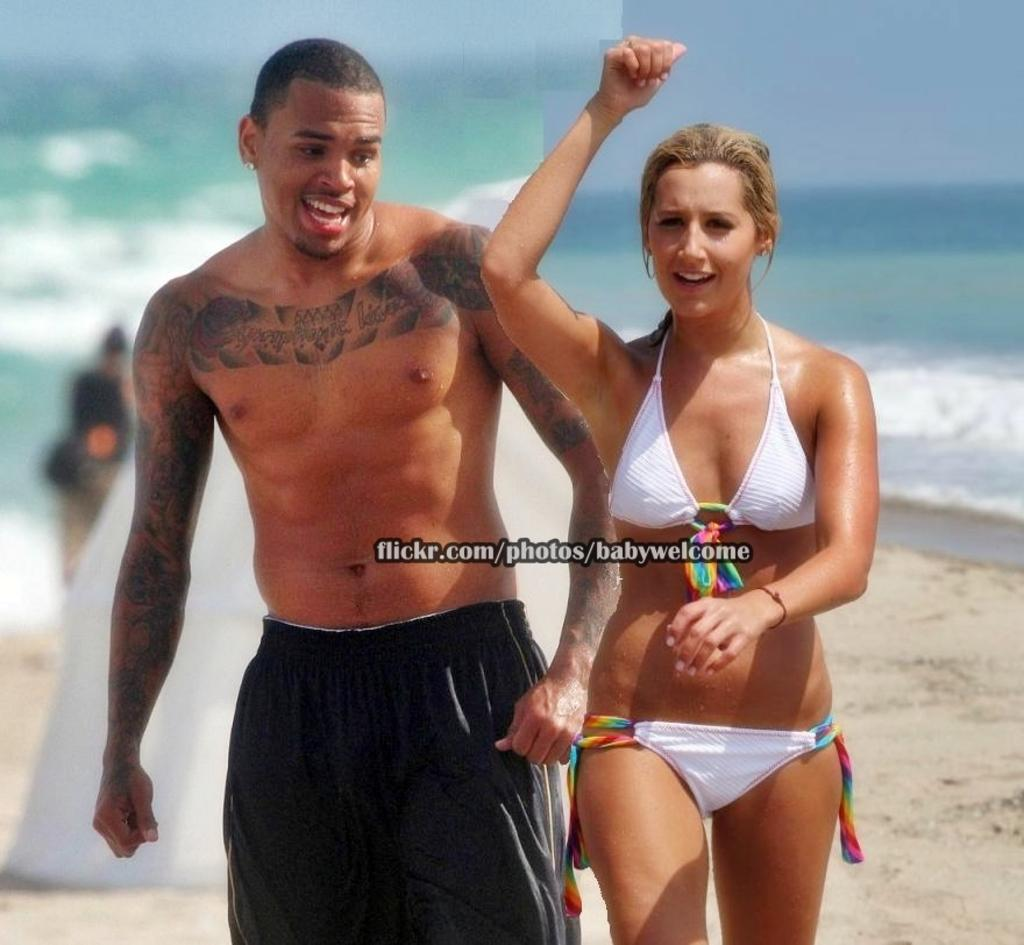How many people are in the center of the image? There are three people in the center of the image: a man and two ladies. What can be seen in the background of the image? There is water and sand in the background of the image. Is there any text visible in the image? Yes, there is some text visible in the image. Can you describe the person in the background of the image? There is another person in the background of the image, but no specific details are provided. What grade of bubble is being used by the man in the image? There is no bubble or any indication of bubbles in the image, so it is not possible to determine the grade of bubble being used. 